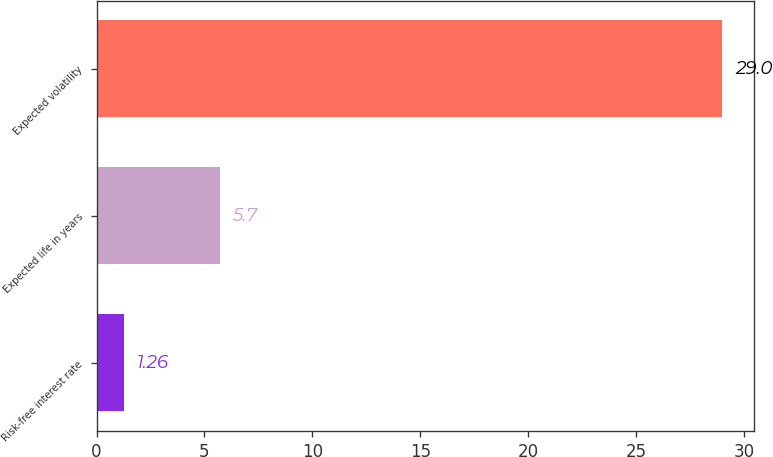Convert chart. <chart><loc_0><loc_0><loc_500><loc_500><bar_chart><fcel>Risk-free interest rate<fcel>Expected life in years<fcel>Expected volatility<nl><fcel>1.26<fcel>5.7<fcel>29<nl></chart> 